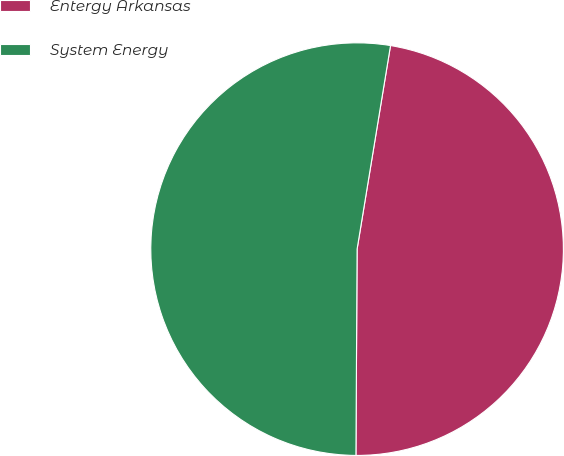Convert chart to OTSL. <chart><loc_0><loc_0><loc_500><loc_500><pie_chart><fcel>Entergy Arkansas<fcel>System Energy<nl><fcel>47.5%<fcel>52.5%<nl></chart> 